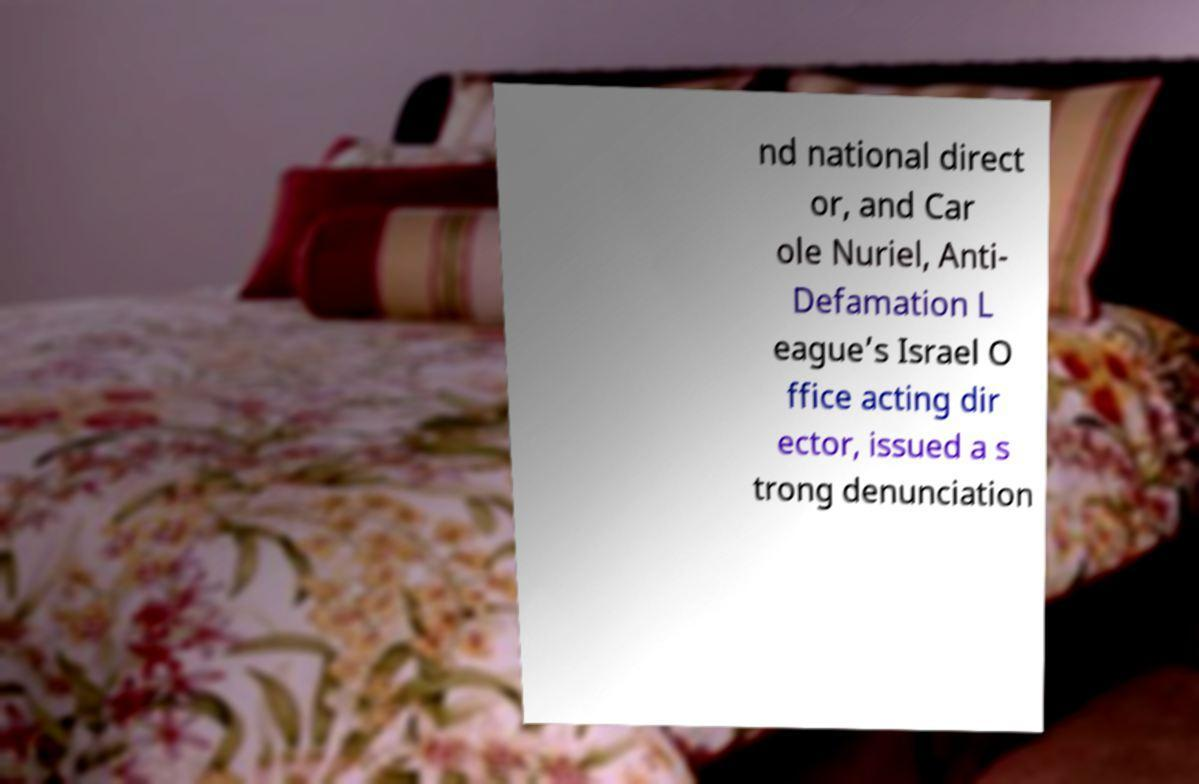Could you extract and type out the text from this image? nd national direct or, and Car ole Nuriel, Anti- Defamation L eague’s Israel O ffice acting dir ector, issued a s trong denunciation 